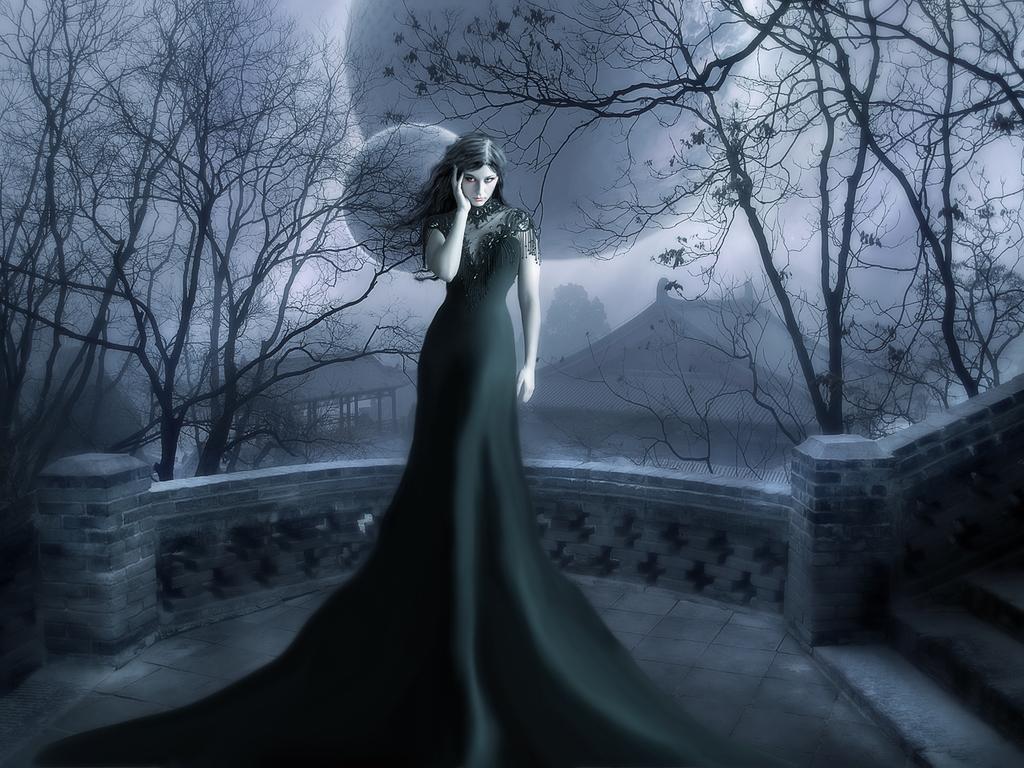Could you give a brief overview of what you see in this image? It is a graphical image in the image we can see a woman and trees and houses. 